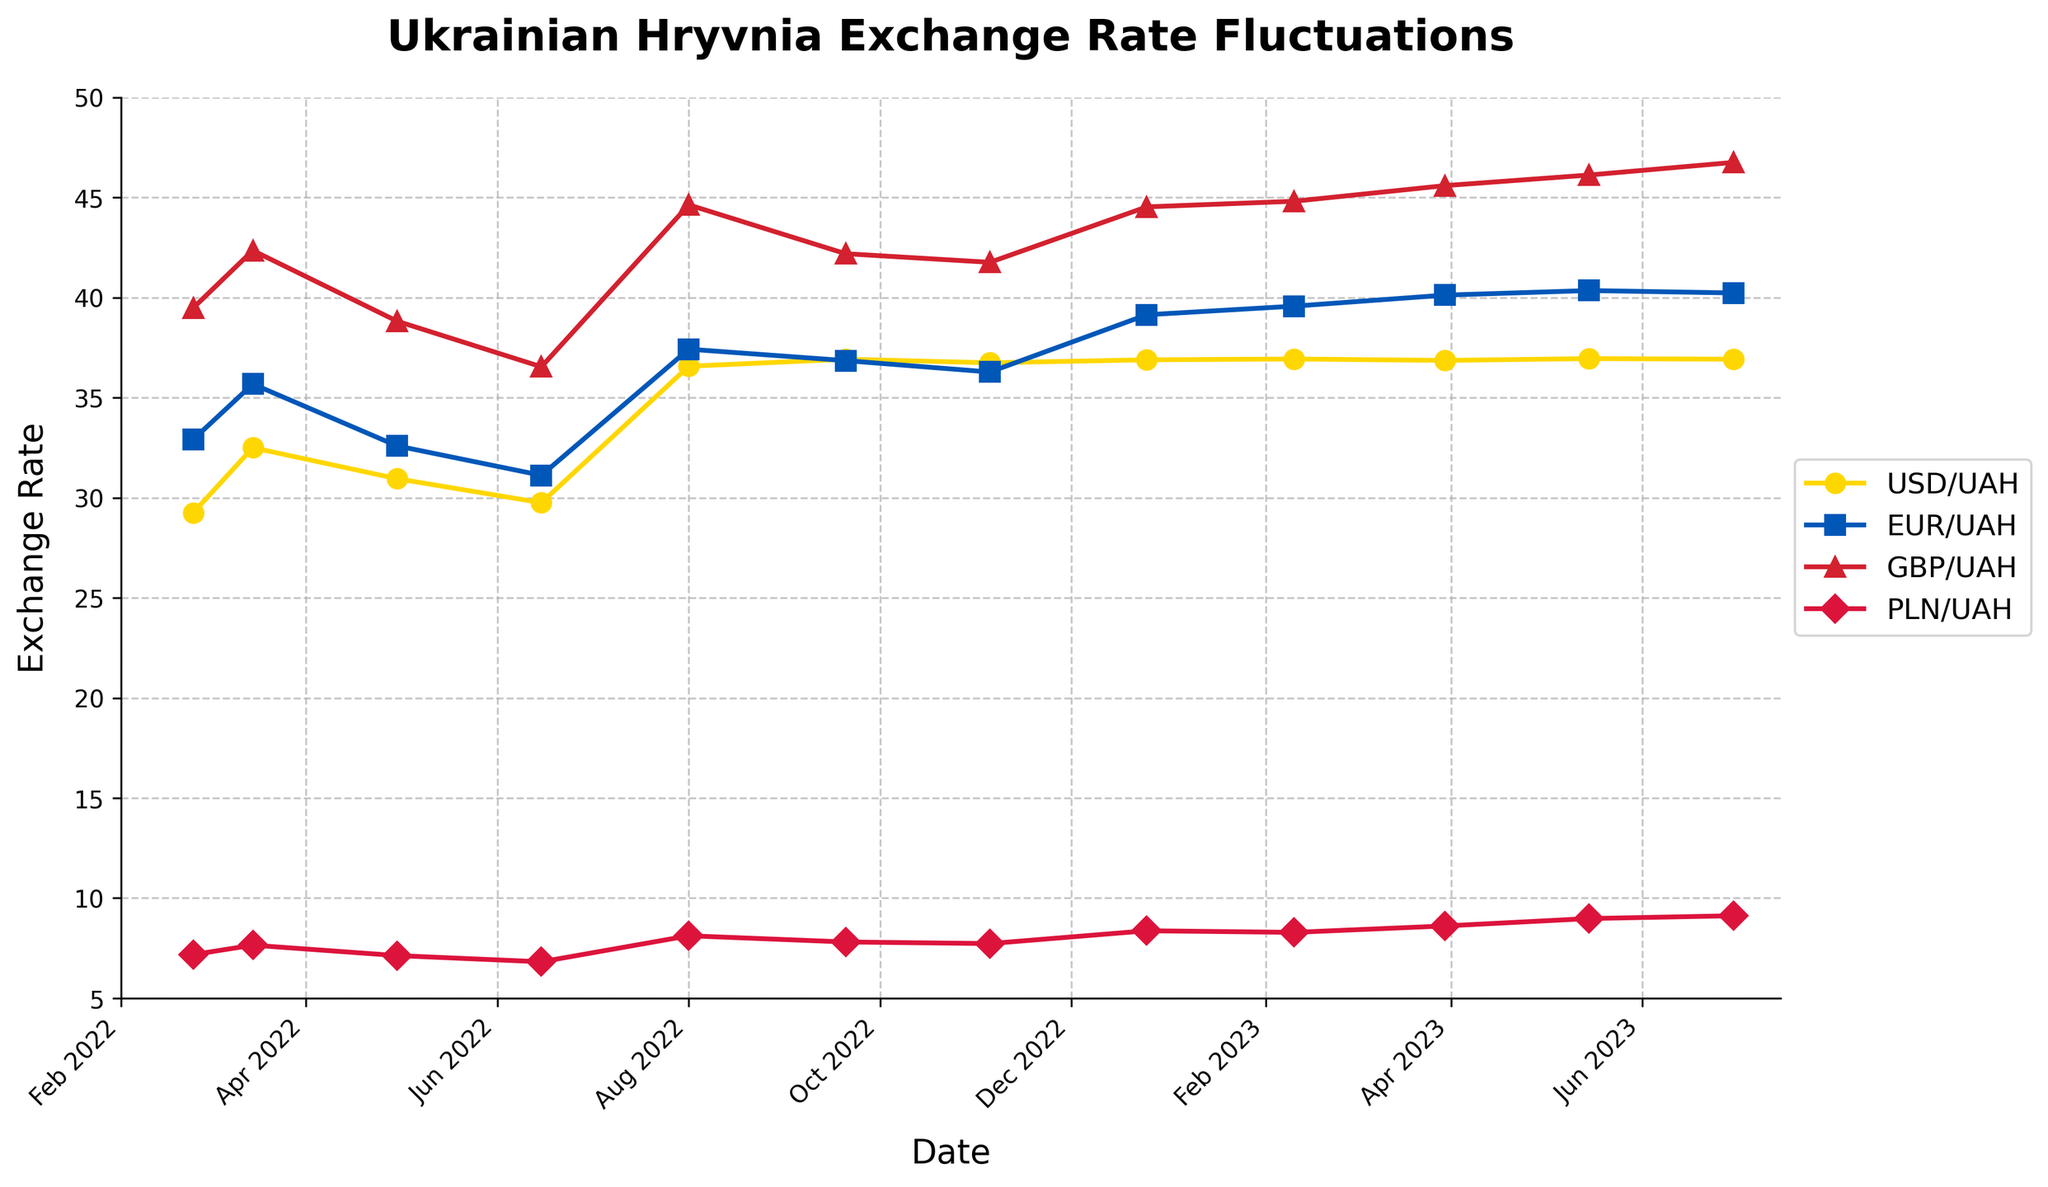Which currency experienced the highest exchange rate against the Ukrainian Hryvnia in May 2023? To determine this, look at the data point for May 2023 and identify the highest value among USD/UAH, EUR/UAH, GBP/UAH, and PLN/UAH. GBP/UAH has the highest value at 46.12.
Answer: GBP/UAH How did the exchange rate for USD/UAH change from the beginning to the end of the given period? Compare the USD/UAH value on 2022-02-24 and 2023-06-30. It increased from 29.25 to 36.92.
Answer: Increased Which currency saw the largest increase in exchange rate from February 2022 to August 2022? Compare the changes from 2022-02-24 to 2022-08-01 for all four currencies. Calculate the differences: USD/UAH (36.57 - 29.25), EUR/UAH (37.42 - 32.91), GBP/UAH (44.63 - 39.48), and PLN/UAH (8.12 - 7.18). The largest difference is for GBP/UAH, which is 5.15.
Answer: GBP/UAH Between August 2022 and February 2023, which currency's exchange rate remained relatively stable? Compare the exchange rates for each currency from 2022-08-01 to 2023-02-10 and look for minimal change. USD/UAH (36.57 to 36.93) had a minimal change of 0.36.
Answer: USD/UAH On which date did PLN/UAH reach its highest value? Check all dates and values for PLN/UAH to find the maximum. The highest value is 9.12 on 2023-06-30.
Answer: 2023-06-30 How does the exchange rate of EUR/UAH in February 2023 compare to its exchange rate in September 2022? Look at the EUR/UAH values on 2023-02-10 and 2022-09-20. It increased from 36.85 to 39.57.
Answer: Increased What is the average exchange rate of GBP/UAH throughout the given period? To find the average, sum all the GBP/UAH values and divide by the number of data points. (39.48 + 42.35 + 38.82 + 36.54 + 44.63 + 42.19 + 41.76 + 44.53 + 44.81 + 45.59 + 46.12 + 46.75) / 12 = 42.56
Answer: 42.56 Which currency showed the least variation in its exchange rate over the given period? Examine the range (max - min) for each currency: USD/UAH (36.95 - 29.25), EUR/UAH (40.35 - 31.12), GBP/UAH (46.75 - 36.54), PLN/UAH (9.12 - 6.82). PLN/UAH has the least variation at 2.30.
Answer: PLN/UAH 